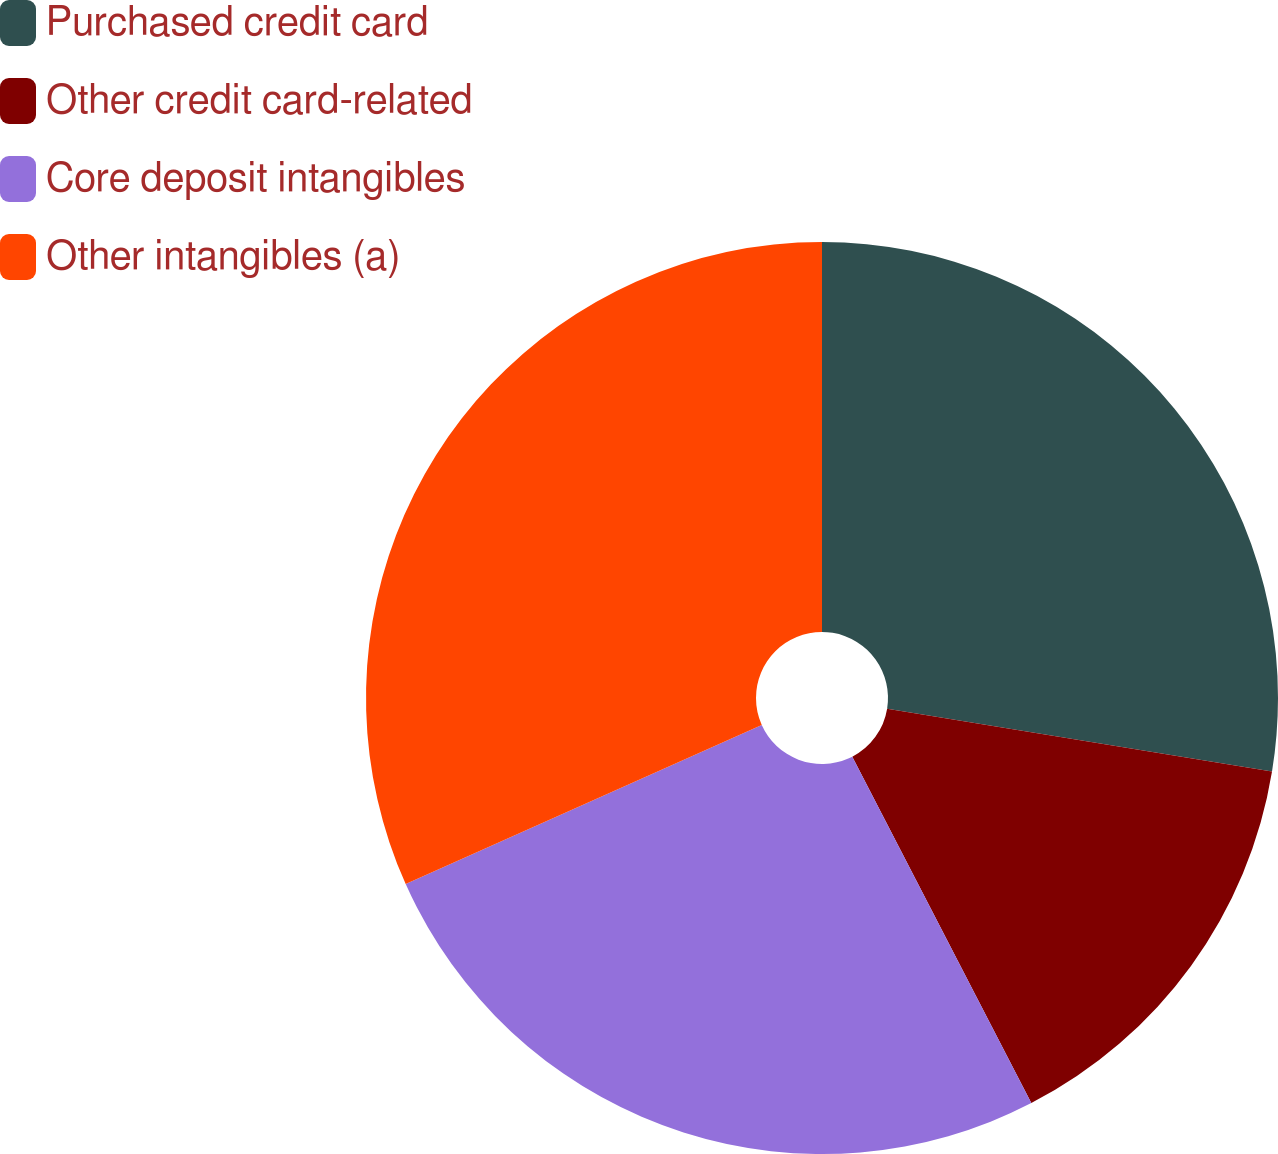Convert chart to OTSL. <chart><loc_0><loc_0><loc_500><loc_500><pie_chart><fcel>Purchased credit card<fcel>Other credit card-related<fcel>Core deposit intangibles<fcel>Other intangibles (a)<nl><fcel>27.58%<fcel>14.83%<fcel>25.9%<fcel>31.69%<nl></chart> 